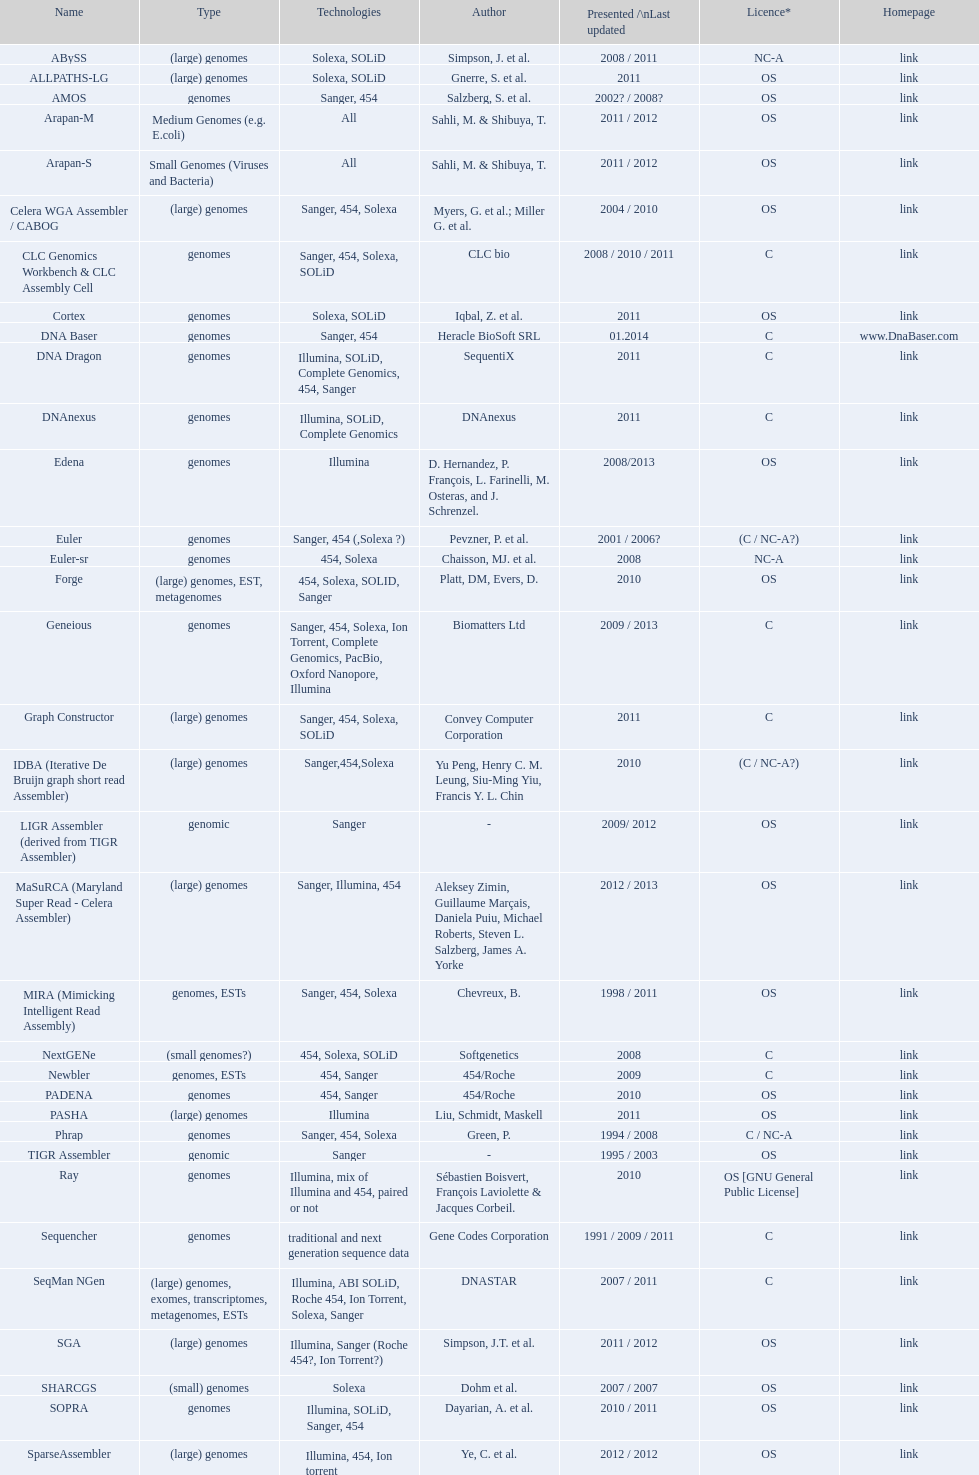What is the total number of technologies classified as "all"? 2. 